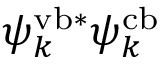Convert formula to latex. <formula><loc_0><loc_0><loc_500><loc_500>\psi _ { k } ^ { v b * } \psi _ { k } ^ { c b }</formula> 